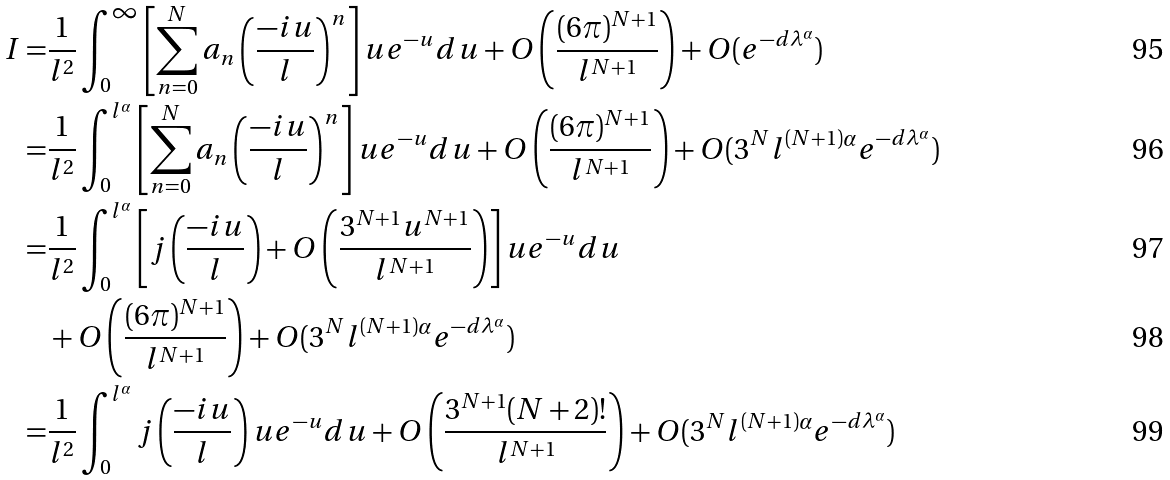<formula> <loc_0><loc_0><loc_500><loc_500>I = & \frac { 1 } { l ^ { 2 } } \int _ { 0 } ^ { \infty } \left [ \sum _ { n = 0 } ^ { N } a _ { n } \left ( \frac { - i u } { l } \right ) ^ { n } \right ] u e ^ { - u } d u + O \left ( \frac { ( 6 \pi ) ^ { N + 1 } } { l ^ { N + 1 } } \right ) + O ( e ^ { - d \lambda ^ { \alpha } } ) \\ = & \frac { 1 } { l ^ { 2 } } \int _ { 0 } ^ { l ^ { \alpha } } \left [ \sum _ { n = 0 } ^ { N } a _ { n } \left ( \frac { - i u } { l } \right ) ^ { n } \right ] u e ^ { - u } d u + O \left ( \frac { ( 6 \pi ) ^ { N + 1 } } { l ^ { N + 1 } } \right ) + O ( 3 ^ { N } l ^ { ( N + 1 ) \alpha } e ^ { - d \lambda ^ { \alpha } } ) \\ = & \frac { 1 } { l ^ { 2 } } \int _ { 0 } ^ { l ^ { \alpha } } \left [ j \left ( \frac { - i u } { l } \right ) + O \left ( \frac { 3 ^ { N + 1 } u ^ { N + 1 } } { l ^ { N + 1 } } \right ) \right ] u e ^ { - u } d u \\ & + O \left ( \frac { ( 6 \pi ) ^ { N + 1 } } { l ^ { N + 1 } } \right ) + O ( 3 ^ { N } l ^ { ( N + 1 ) \alpha } e ^ { - d \lambda ^ { \alpha } } ) \\ = & \frac { 1 } { l ^ { 2 } } \int _ { 0 } ^ { l ^ { \alpha } } j \left ( \frac { - i u } { l } \right ) u e ^ { - u } d u + O \left ( \frac { 3 ^ { N + 1 } ( N + 2 ) ! } { l ^ { N + 1 } } \right ) + O ( 3 ^ { N } l ^ { ( N + 1 ) \alpha } e ^ { - d \lambda ^ { \alpha } } )</formula> 